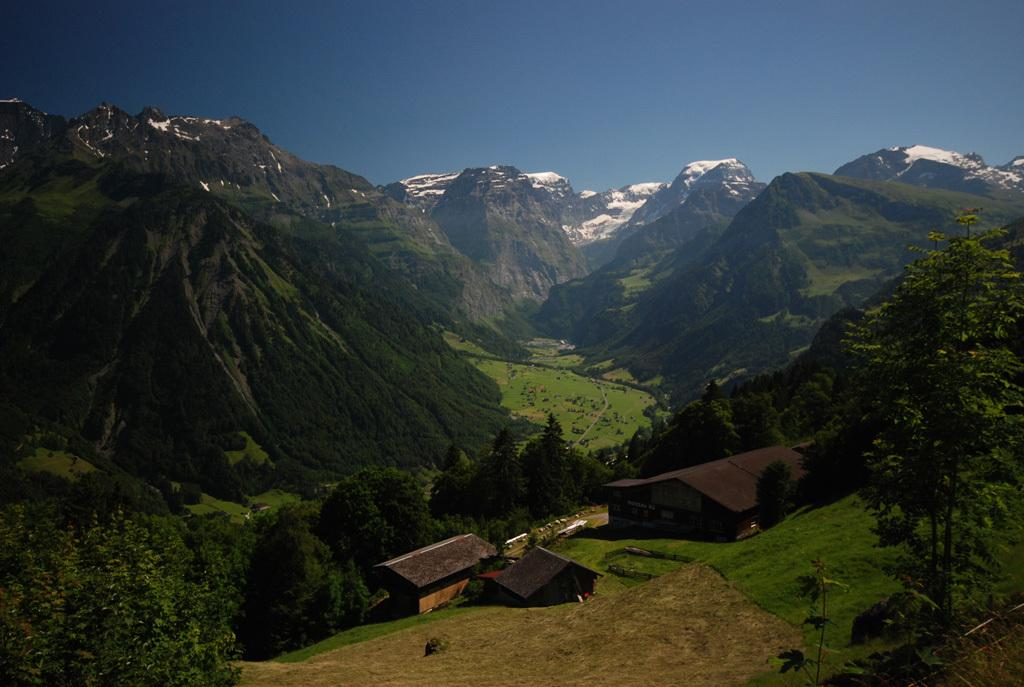What type of structures are present in the image? There are houses in the image. What can be seen near the houses? There are many trees near the houses. What is visible in the distance behind the houses? There are mountains visible in the background of the image. What color is the sky in the background of the image? The sky is blue in the background of the image. How does the taste of the ladybug compare to the taste of the houses in the image? There are no ladybugs or references to taste in the image; it features houses, trees, mountains, and a blue sky. 